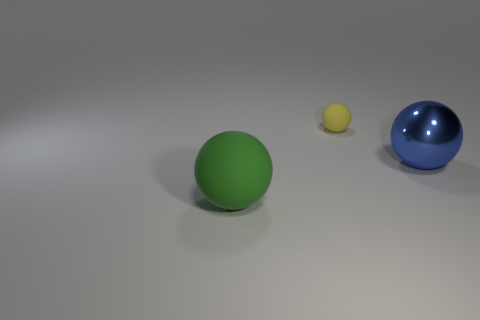Is the number of matte things that are on the left side of the large shiny sphere greater than the number of large balls?
Provide a succinct answer. No. Are there the same number of yellow matte spheres on the left side of the yellow sphere and big things that are behind the big green matte object?
Ensure brevity in your answer.  No. There is a object that is behind the large matte object and left of the blue ball; what color is it?
Ensure brevity in your answer.  Yellow. Is there anything else that has the same size as the green rubber ball?
Provide a succinct answer. Yes. Are there more spheres that are left of the small yellow object than large metallic things that are behind the large blue shiny object?
Provide a short and direct response. Yes. There is a green matte sphere in front of the blue object; is its size the same as the shiny sphere?
Keep it short and to the point. Yes. There is a tiny yellow matte thing left of the object that is to the right of the tiny yellow matte object; what number of things are to the right of it?
Ensure brevity in your answer.  1. There is a thing that is on the left side of the metal thing and in front of the yellow object; what size is it?
Make the answer very short. Large. What number of other things are there of the same shape as the large metallic object?
Your answer should be compact. 2. There is a large matte sphere; how many rubber objects are behind it?
Your answer should be compact. 1. 